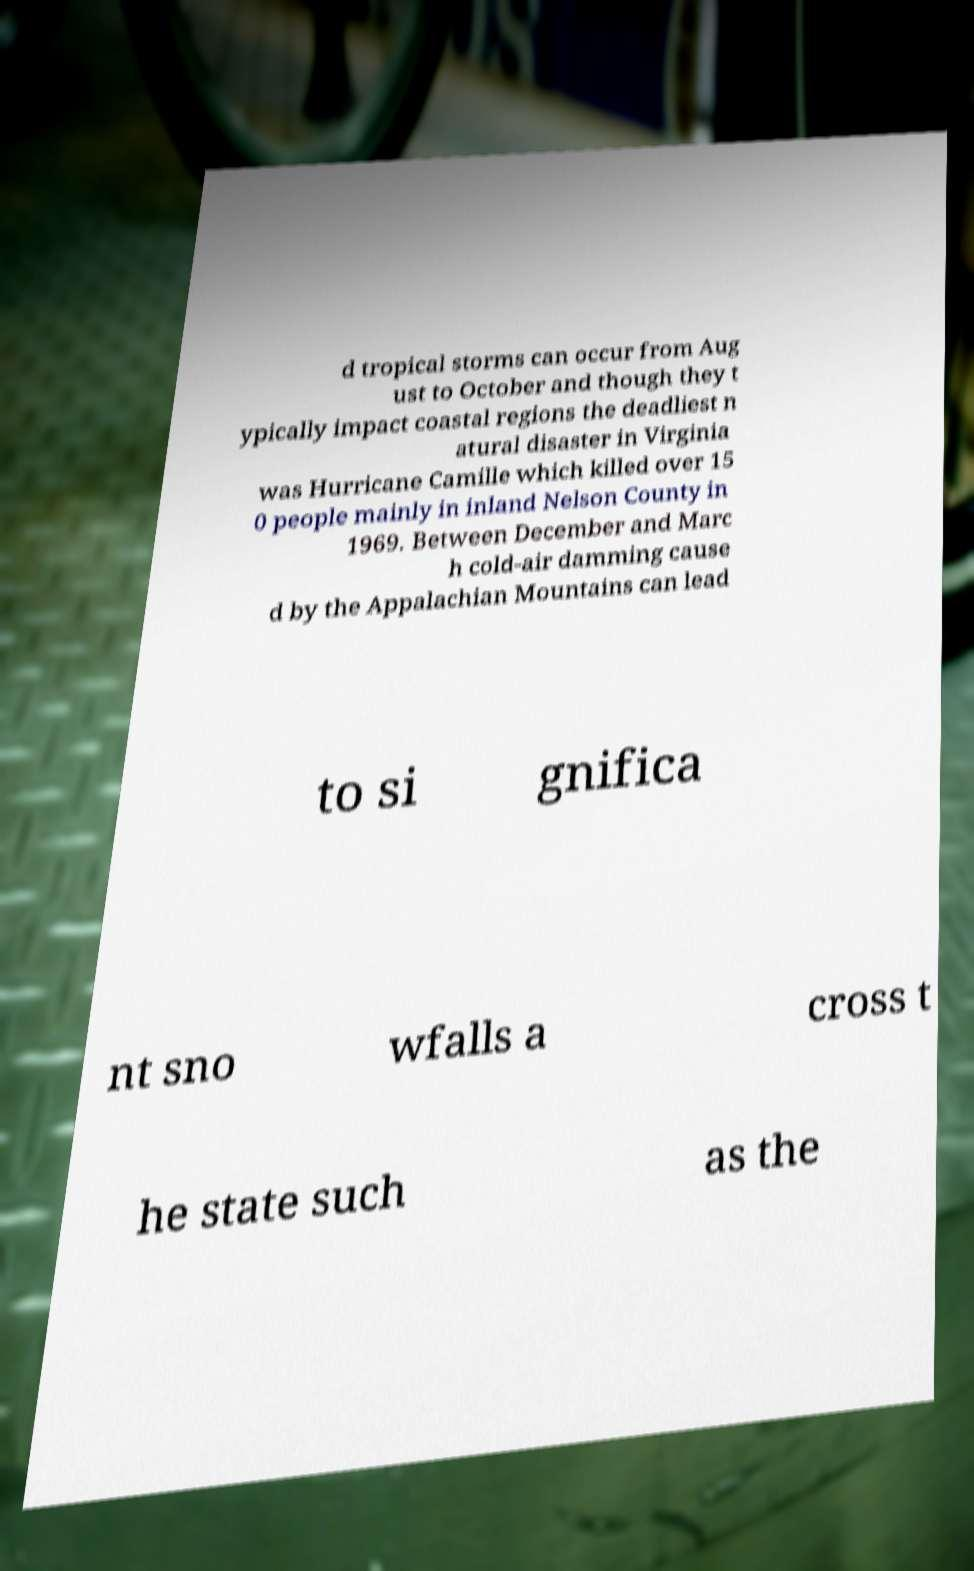Please identify and transcribe the text found in this image. d tropical storms can occur from Aug ust to October and though they t ypically impact coastal regions the deadliest n atural disaster in Virginia was Hurricane Camille which killed over 15 0 people mainly in inland Nelson County in 1969. Between December and Marc h cold-air damming cause d by the Appalachian Mountains can lead to si gnifica nt sno wfalls a cross t he state such as the 